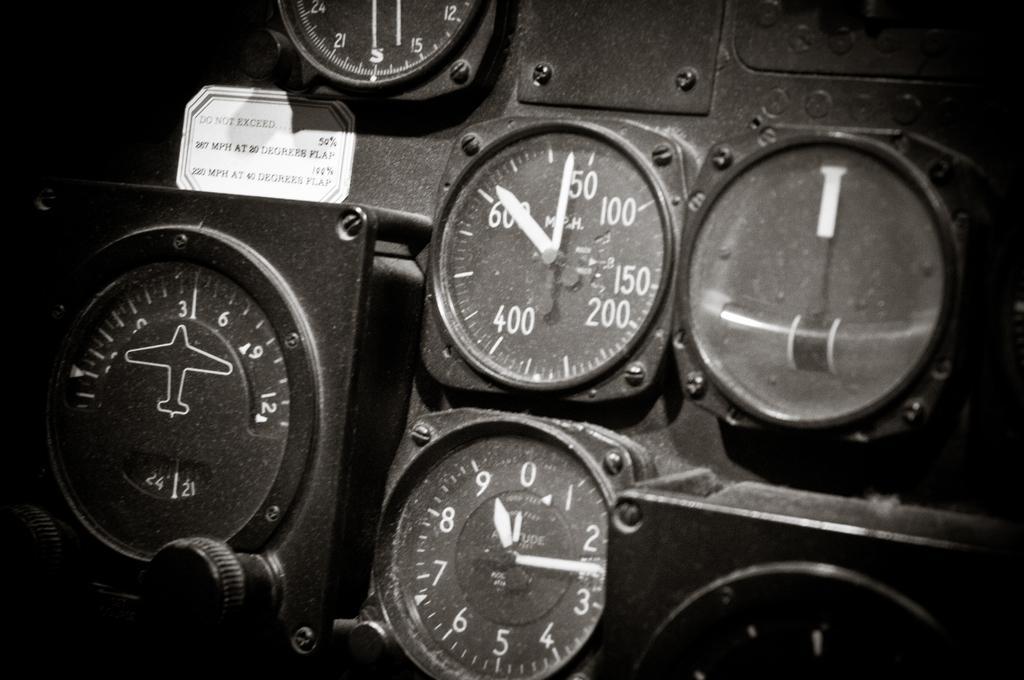How would you summarize this image in a sentence or two? In this image I can see few meters. On the top left side of this image I can see a white colour thing and on it I can see something is written. I can also see this image is black and white in colour. 